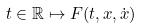Convert formula to latex. <formula><loc_0><loc_0><loc_500><loc_500>t \in \mathbb { R } \mapsto F ( t , x , \dot { x } )</formula> 